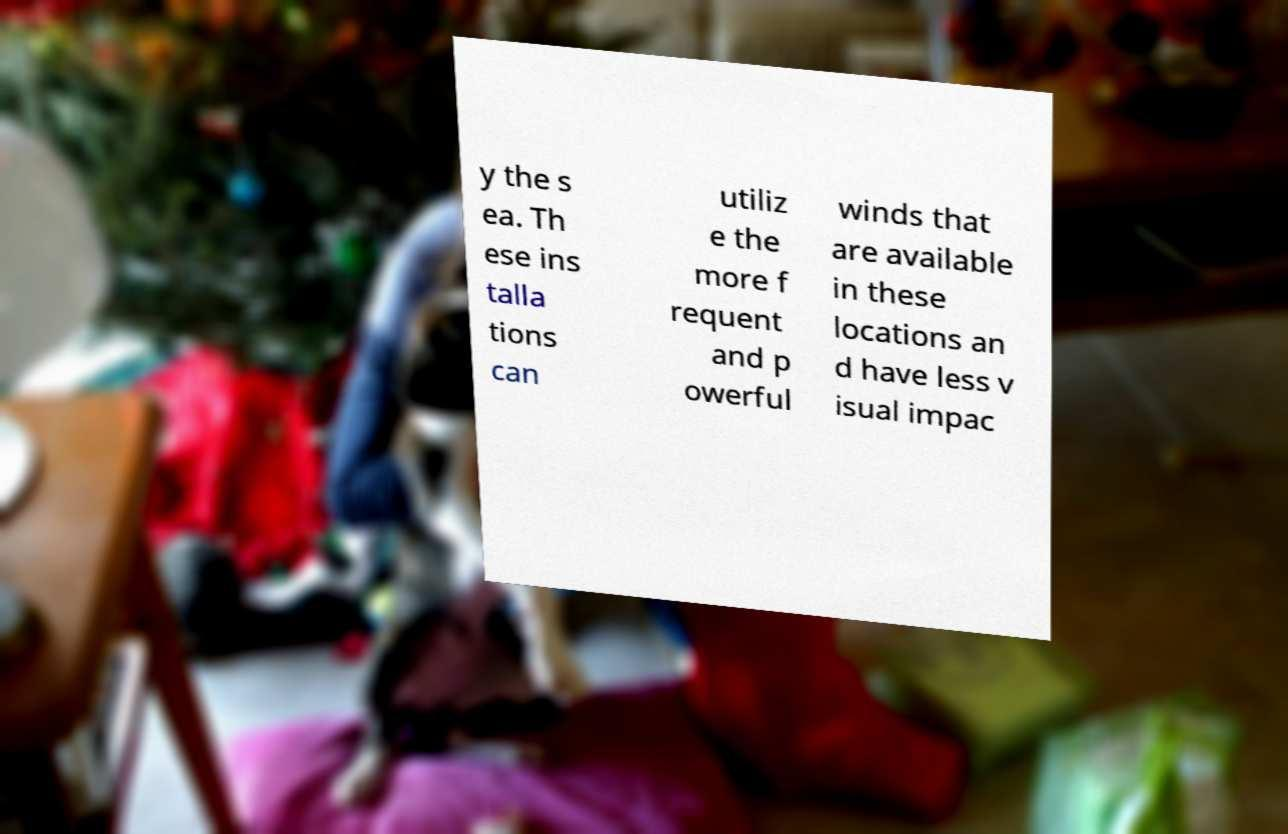Please read and relay the text visible in this image. What does it say? y the s ea. Th ese ins talla tions can utiliz e the more f requent and p owerful winds that are available in these locations an d have less v isual impac 